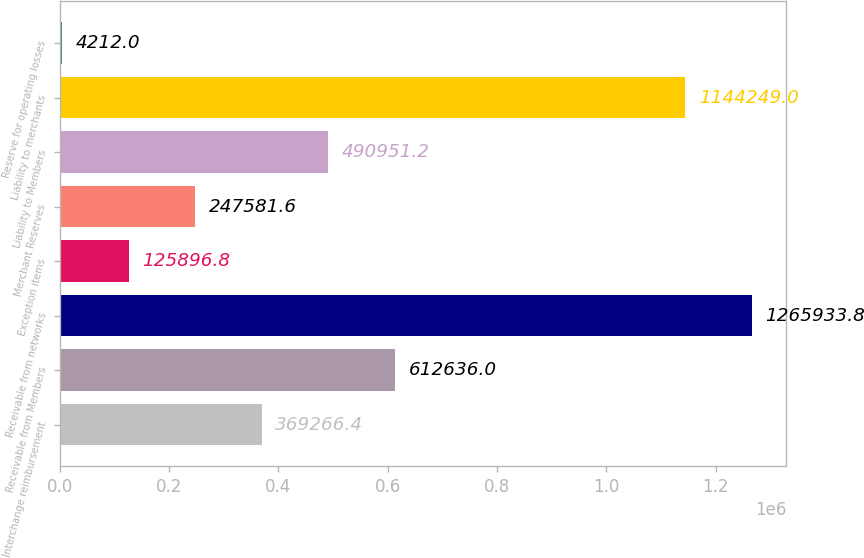Convert chart. <chart><loc_0><loc_0><loc_500><loc_500><bar_chart><fcel>Interchange reimbursement<fcel>Receivable from Members<fcel>Receivable from networks<fcel>Exception items<fcel>Merchant Reserves<fcel>Liability to Members<fcel>Liability to merchants<fcel>Reserve for operating losses<nl><fcel>369266<fcel>612636<fcel>1.26593e+06<fcel>125897<fcel>247582<fcel>490951<fcel>1.14425e+06<fcel>4212<nl></chart> 